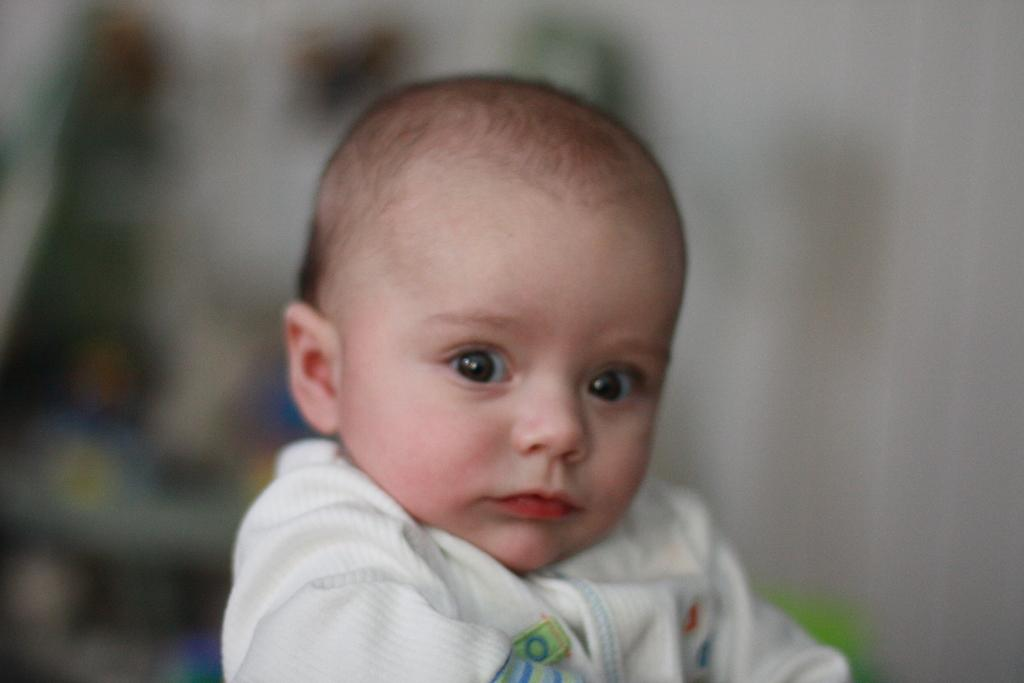What is the main subject of the image? There is a kid in the image. Can you describe the background of the image? The background of the image is blurred. What type of shoe is the owl wearing in the image? There is no owl or shoe present in the image; it features a kid with a blurred background. 